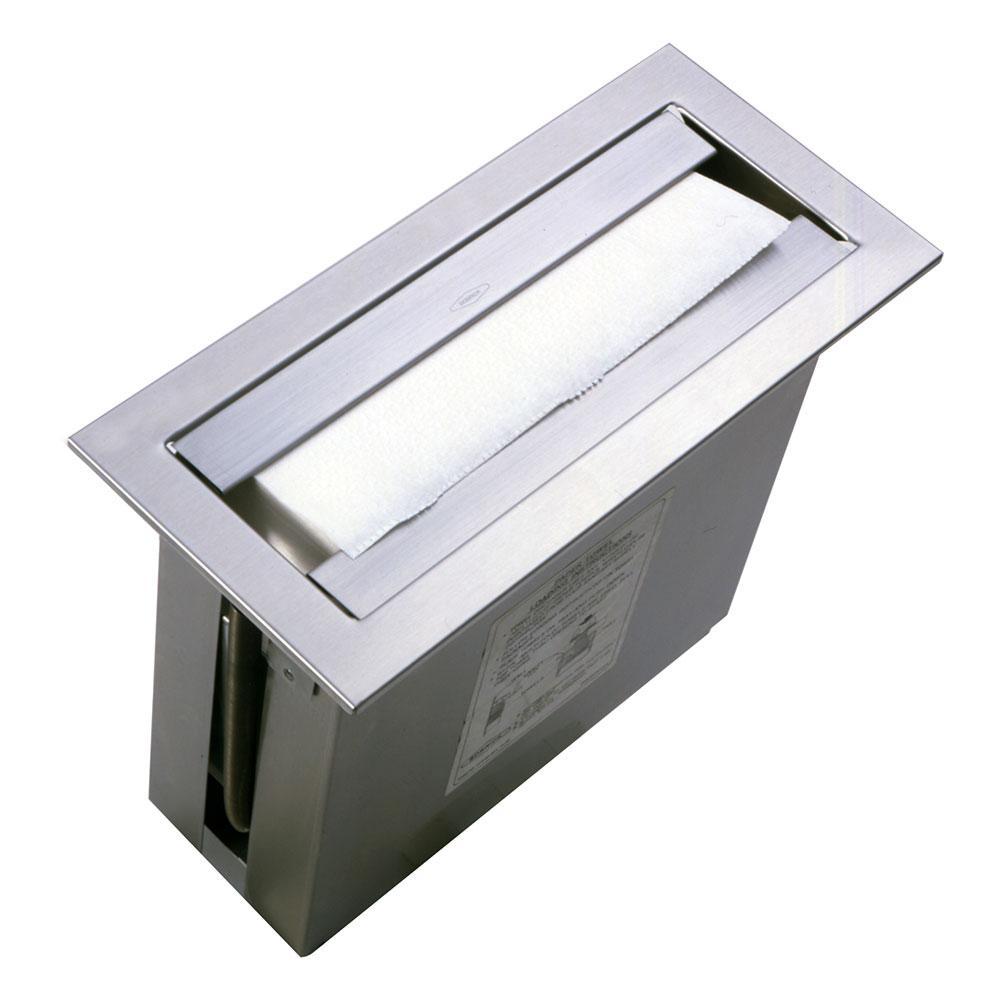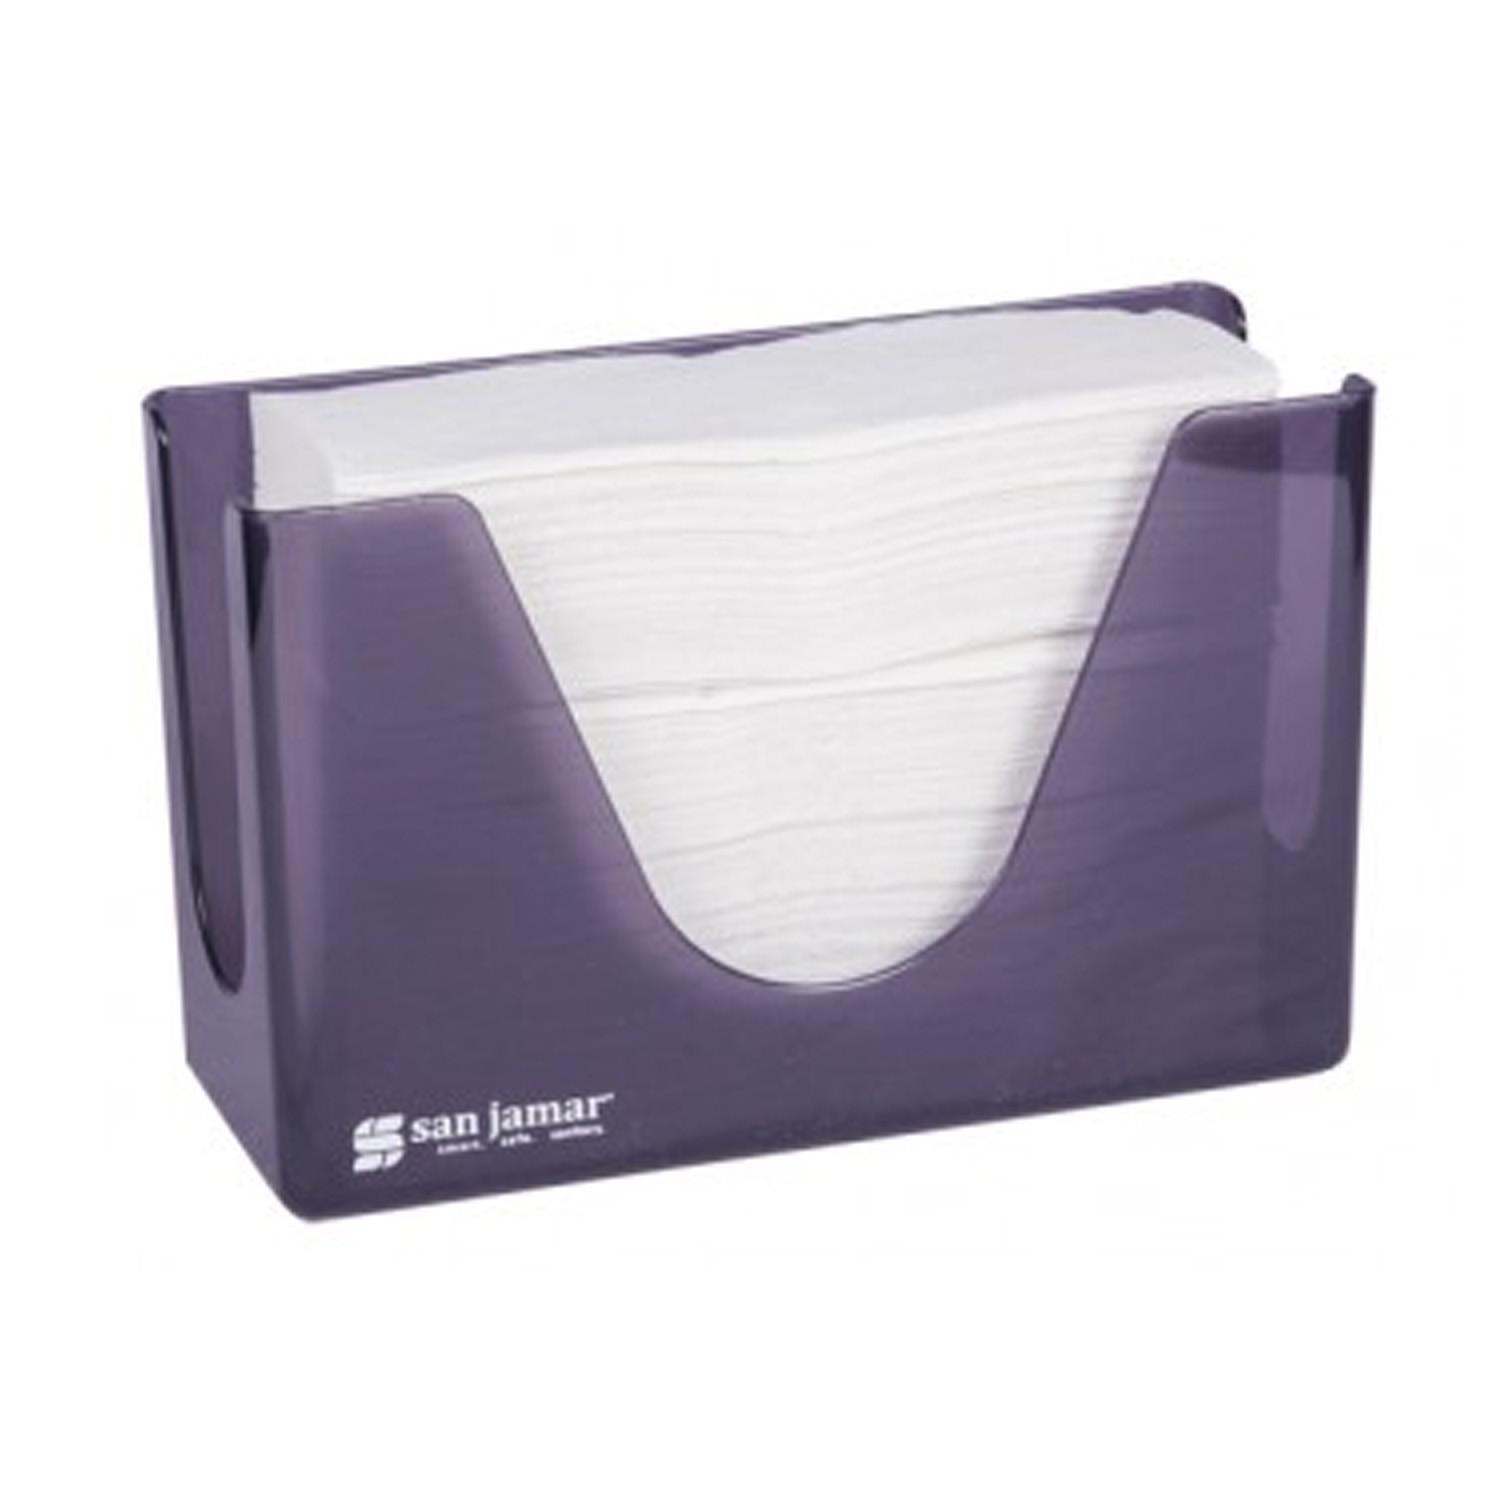The first image is the image on the left, the second image is the image on the right. Considering the images on both sides, is "Different style holders are shown in the left and right images, and the right image features an upright oblong opaque holder with a paper towel sticking out of its top." valid? Answer yes or no. No. 